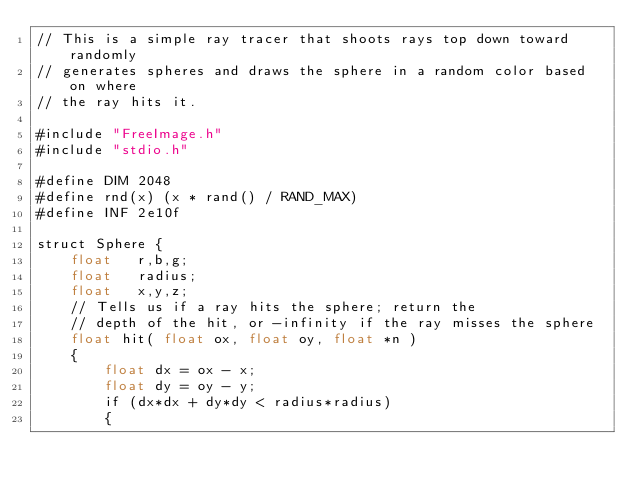<code> <loc_0><loc_0><loc_500><loc_500><_Cuda_>// This is a simple ray tracer that shoots rays top down toward randomly
// generates spheres and draws the sphere in a random color based on where
// the ray hits it.

#include "FreeImage.h"
#include "stdio.h"

#define DIM 2048
#define rnd(x) (x * rand() / RAND_MAX)
#define INF 2e10f

struct Sphere {
    float   r,b,g;
    float   radius;
    float   x,y,z;
    // Tells us if a ray hits the sphere; return the
    // depth of the hit, or -infinity if the ray misses the sphere
    float hit( float ox, float oy, float *n ) 
    {
        float dx = ox - x;
        float dy = oy - y;
        if (dx*dx + dy*dy < radius*radius)
        {</code> 